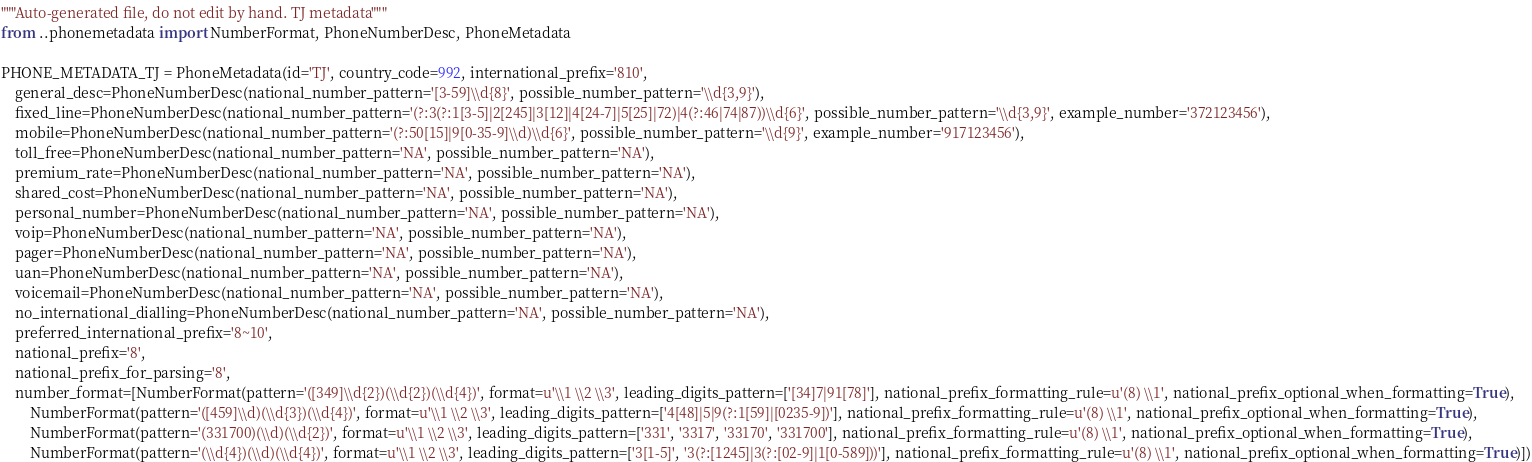<code> <loc_0><loc_0><loc_500><loc_500><_Python_>"""Auto-generated file, do not edit by hand. TJ metadata"""
from ..phonemetadata import NumberFormat, PhoneNumberDesc, PhoneMetadata

PHONE_METADATA_TJ = PhoneMetadata(id='TJ', country_code=992, international_prefix='810',
    general_desc=PhoneNumberDesc(national_number_pattern='[3-59]\\d{8}', possible_number_pattern='\\d{3,9}'),
    fixed_line=PhoneNumberDesc(national_number_pattern='(?:3(?:1[3-5]|2[245]|3[12]|4[24-7]|5[25]|72)|4(?:46|74|87))\\d{6}', possible_number_pattern='\\d{3,9}', example_number='372123456'),
    mobile=PhoneNumberDesc(national_number_pattern='(?:50[15]|9[0-35-9]\\d)\\d{6}', possible_number_pattern='\\d{9}', example_number='917123456'),
    toll_free=PhoneNumberDesc(national_number_pattern='NA', possible_number_pattern='NA'),
    premium_rate=PhoneNumberDesc(national_number_pattern='NA', possible_number_pattern='NA'),
    shared_cost=PhoneNumberDesc(national_number_pattern='NA', possible_number_pattern='NA'),
    personal_number=PhoneNumberDesc(national_number_pattern='NA', possible_number_pattern='NA'),
    voip=PhoneNumberDesc(national_number_pattern='NA', possible_number_pattern='NA'),
    pager=PhoneNumberDesc(national_number_pattern='NA', possible_number_pattern='NA'),
    uan=PhoneNumberDesc(national_number_pattern='NA', possible_number_pattern='NA'),
    voicemail=PhoneNumberDesc(national_number_pattern='NA', possible_number_pattern='NA'),
    no_international_dialling=PhoneNumberDesc(national_number_pattern='NA', possible_number_pattern='NA'),
    preferred_international_prefix='8~10',
    national_prefix='8',
    national_prefix_for_parsing='8',
    number_format=[NumberFormat(pattern='([349]\\d{2})(\\d{2})(\\d{4})', format=u'\\1 \\2 \\3', leading_digits_pattern=['[34]7|91[78]'], national_prefix_formatting_rule=u'(8) \\1', national_prefix_optional_when_formatting=True),
        NumberFormat(pattern='([459]\\d)(\\d{3})(\\d{4})', format=u'\\1 \\2 \\3', leading_digits_pattern=['4[48]|5|9(?:1[59]|[0235-9])'], national_prefix_formatting_rule=u'(8) \\1', national_prefix_optional_when_formatting=True),
        NumberFormat(pattern='(331700)(\\d)(\\d{2})', format=u'\\1 \\2 \\3', leading_digits_pattern=['331', '3317', '33170', '331700'], national_prefix_formatting_rule=u'(8) \\1', national_prefix_optional_when_formatting=True),
        NumberFormat(pattern='(\\d{4})(\\d)(\\d{4})', format=u'\\1 \\2 \\3', leading_digits_pattern=['3[1-5]', '3(?:[1245]|3(?:[02-9]|1[0-589]))'], national_prefix_formatting_rule=u'(8) \\1', national_prefix_optional_when_formatting=True)])
</code> 